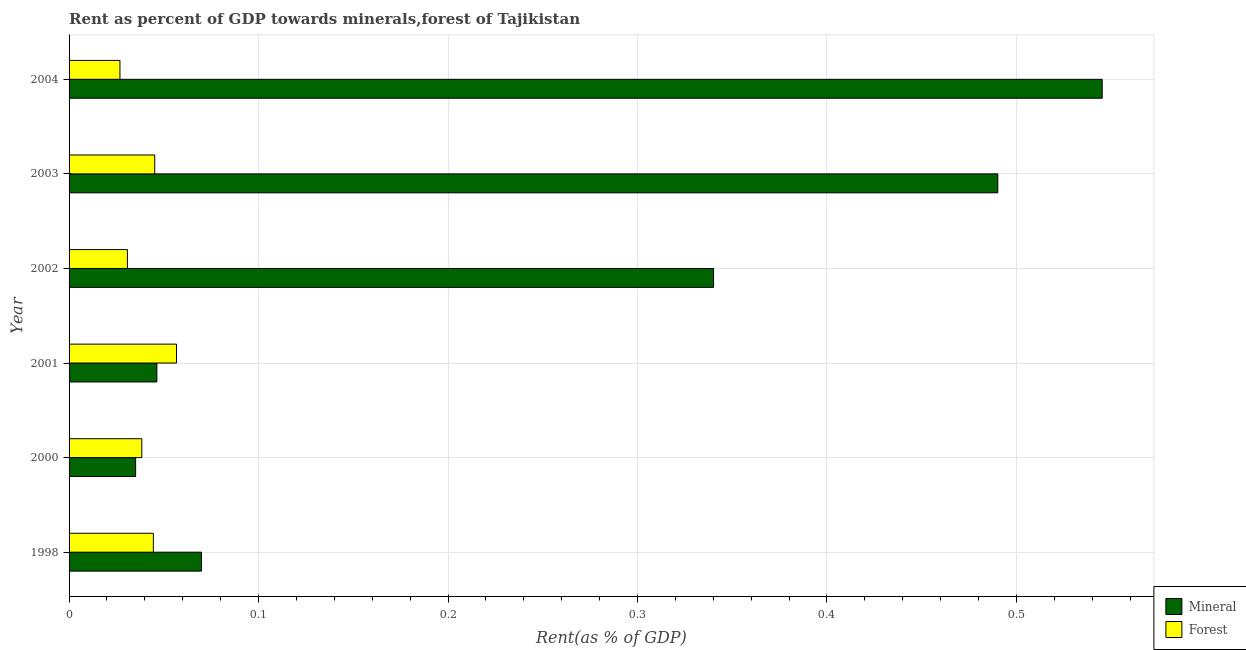How many groups of bars are there?
Ensure brevity in your answer.  6. Are the number of bars on each tick of the Y-axis equal?
Offer a very short reply. Yes. How many bars are there on the 5th tick from the bottom?
Provide a succinct answer. 2. In how many cases, is the number of bars for a given year not equal to the number of legend labels?
Ensure brevity in your answer.  0. What is the forest rent in 1998?
Keep it short and to the point. 0.04. Across all years, what is the maximum mineral rent?
Your answer should be compact. 0.55. Across all years, what is the minimum mineral rent?
Offer a terse response. 0.04. In which year was the forest rent maximum?
Provide a short and direct response. 2001. In which year was the mineral rent minimum?
Keep it short and to the point. 2000. What is the total mineral rent in the graph?
Provide a succinct answer. 1.53. What is the difference between the forest rent in 2001 and that in 2003?
Your answer should be compact. 0.01. What is the difference between the forest rent in 2004 and the mineral rent in 1998?
Provide a succinct answer. -0.04. What is the average forest rent per year?
Offer a very short reply. 0.04. In the year 2003, what is the difference between the forest rent and mineral rent?
Give a very brief answer. -0.45. What is the ratio of the mineral rent in 2000 to that in 2001?
Give a very brief answer. 0.76. What is the difference between the highest and the second highest mineral rent?
Give a very brief answer. 0.06. What is the difference between the highest and the lowest mineral rent?
Offer a very short reply. 0.51. In how many years, is the forest rent greater than the average forest rent taken over all years?
Your response must be concise. 3. What does the 1st bar from the top in 2003 represents?
Your answer should be compact. Forest. What does the 2nd bar from the bottom in 1998 represents?
Provide a succinct answer. Forest. How many years are there in the graph?
Keep it short and to the point. 6. Does the graph contain grids?
Your answer should be compact. Yes. What is the title of the graph?
Offer a very short reply. Rent as percent of GDP towards minerals,forest of Tajikistan. What is the label or title of the X-axis?
Your response must be concise. Rent(as % of GDP). What is the Rent(as % of GDP) of Mineral in 1998?
Your response must be concise. 0.07. What is the Rent(as % of GDP) in Forest in 1998?
Your answer should be compact. 0.04. What is the Rent(as % of GDP) in Mineral in 2000?
Offer a terse response. 0.04. What is the Rent(as % of GDP) in Forest in 2000?
Ensure brevity in your answer.  0.04. What is the Rent(as % of GDP) in Mineral in 2001?
Provide a succinct answer. 0.05. What is the Rent(as % of GDP) in Forest in 2001?
Keep it short and to the point. 0.06. What is the Rent(as % of GDP) of Mineral in 2002?
Your response must be concise. 0.34. What is the Rent(as % of GDP) of Forest in 2002?
Keep it short and to the point. 0.03. What is the Rent(as % of GDP) in Mineral in 2003?
Keep it short and to the point. 0.49. What is the Rent(as % of GDP) in Forest in 2003?
Your answer should be compact. 0.05. What is the Rent(as % of GDP) of Mineral in 2004?
Your answer should be very brief. 0.55. What is the Rent(as % of GDP) of Forest in 2004?
Give a very brief answer. 0.03. Across all years, what is the maximum Rent(as % of GDP) of Mineral?
Offer a very short reply. 0.55. Across all years, what is the maximum Rent(as % of GDP) in Forest?
Offer a very short reply. 0.06. Across all years, what is the minimum Rent(as % of GDP) of Mineral?
Your response must be concise. 0.04. Across all years, what is the minimum Rent(as % of GDP) in Forest?
Give a very brief answer. 0.03. What is the total Rent(as % of GDP) of Mineral in the graph?
Keep it short and to the point. 1.53. What is the total Rent(as % of GDP) in Forest in the graph?
Make the answer very short. 0.24. What is the difference between the Rent(as % of GDP) of Mineral in 1998 and that in 2000?
Make the answer very short. 0.03. What is the difference between the Rent(as % of GDP) in Forest in 1998 and that in 2000?
Provide a short and direct response. 0.01. What is the difference between the Rent(as % of GDP) of Mineral in 1998 and that in 2001?
Give a very brief answer. 0.02. What is the difference between the Rent(as % of GDP) of Forest in 1998 and that in 2001?
Your response must be concise. -0.01. What is the difference between the Rent(as % of GDP) of Mineral in 1998 and that in 2002?
Provide a succinct answer. -0.27. What is the difference between the Rent(as % of GDP) in Forest in 1998 and that in 2002?
Provide a succinct answer. 0.01. What is the difference between the Rent(as % of GDP) in Mineral in 1998 and that in 2003?
Offer a very short reply. -0.42. What is the difference between the Rent(as % of GDP) in Forest in 1998 and that in 2003?
Give a very brief answer. -0. What is the difference between the Rent(as % of GDP) in Mineral in 1998 and that in 2004?
Keep it short and to the point. -0.48. What is the difference between the Rent(as % of GDP) of Forest in 1998 and that in 2004?
Provide a short and direct response. 0.02. What is the difference between the Rent(as % of GDP) of Mineral in 2000 and that in 2001?
Give a very brief answer. -0.01. What is the difference between the Rent(as % of GDP) of Forest in 2000 and that in 2001?
Provide a succinct answer. -0.02. What is the difference between the Rent(as % of GDP) of Mineral in 2000 and that in 2002?
Offer a terse response. -0.3. What is the difference between the Rent(as % of GDP) of Forest in 2000 and that in 2002?
Offer a terse response. 0.01. What is the difference between the Rent(as % of GDP) of Mineral in 2000 and that in 2003?
Your answer should be compact. -0.46. What is the difference between the Rent(as % of GDP) of Forest in 2000 and that in 2003?
Provide a succinct answer. -0.01. What is the difference between the Rent(as % of GDP) of Mineral in 2000 and that in 2004?
Provide a short and direct response. -0.51. What is the difference between the Rent(as % of GDP) in Forest in 2000 and that in 2004?
Offer a very short reply. 0.01. What is the difference between the Rent(as % of GDP) of Mineral in 2001 and that in 2002?
Keep it short and to the point. -0.29. What is the difference between the Rent(as % of GDP) of Forest in 2001 and that in 2002?
Provide a short and direct response. 0.03. What is the difference between the Rent(as % of GDP) in Mineral in 2001 and that in 2003?
Provide a succinct answer. -0.44. What is the difference between the Rent(as % of GDP) in Forest in 2001 and that in 2003?
Give a very brief answer. 0.01. What is the difference between the Rent(as % of GDP) of Mineral in 2001 and that in 2004?
Give a very brief answer. -0.5. What is the difference between the Rent(as % of GDP) in Forest in 2001 and that in 2004?
Ensure brevity in your answer.  0.03. What is the difference between the Rent(as % of GDP) of Mineral in 2002 and that in 2003?
Ensure brevity in your answer.  -0.15. What is the difference between the Rent(as % of GDP) in Forest in 2002 and that in 2003?
Offer a very short reply. -0.01. What is the difference between the Rent(as % of GDP) in Mineral in 2002 and that in 2004?
Ensure brevity in your answer.  -0.21. What is the difference between the Rent(as % of GDP) in Forest in 2002 and that in 2004?
Provide a short and direct response. 0. What is the difference between the Rent(as % of GDP) of Mineral in 2003 and that in 2004?
Provide a short and direct response. -0.06. What is the difference between the Rent(as % of GDP) of Forest in 2003 and that in 2004?
Your response must be concise. 0.02. What is the difference between the Rent(as % of GDP) of Mineral in 1998 and the Rent(as % of GDP) of Forest in 2000?
Ensure brevity in your answer.  0.03. What is the difference between the Rent(as % of GDP) in Mineral in 1998 and the Rent(as % of GDP) in Forest in 2001?
Ensure brevity in your answer.  0.01. What is the difference between the Rent(as % of GDP) in Mineral in 1998 and the Rent(as % of GDP) in Forest in 2002?
Offer a very short reply. 0.04. What is the difference between the Rent(as % of GDP) in Mineral in 1998 and the Rent(as % of GDP) in Forest in 2003?
Give a very brief answer. 0.02. What is the difference between the Rent(as % of GDP) in Mineral in 1998 and the Rent(as % of GDP) in Forest in 2004?
Offer a terse response. 0.04. What is the difference between the Rent(as % of GDP) of Mineral in 2000 and the Rent(as % of GDP) of Forest in 2001?
Your answer should be very brief. -0.02. What is the difference between the Rent(as % of GDP) in Mineral in 2000 and the Rent(as % of GDP) in Forest in 2002?
Provide a succinct answer. 0. What is the difference between the Rent(as % of GDP) in Mineral in 2000 and the Rent(as % of GDP) in Forest in 2003?
Your response must be concise. -0.01. What is the difference between the Rent(as % of GDP) of Mineral in 2000 and the Rent(as % of GDP) of Forest in 2004?
Provide a succinct answer. 0.01. What is the difference between the Rent(as % of GDP) of Mineral in 2001 and the Rent(as % of GDP) of Forest in 2002?
Give a very brief answer. 0.02. What is the difference between the Rent(as % of GDP) in Mineral in 2001 and the Rent(as % of GDP) in Forest in 2003?
Give a very brief answer. 0. What is the difference between the Rent(as % of GDP) of Mineral in 2001 and the Rent(as % of GDP) of Forest in 2004?
Offer a very short reply. 0.02. What is the difference between the Rent(as % of GDP) in Mineral in 2002 and the Rent(as % of GDP) in Forest in 2003?
Offer a very short reply. 0.29. What is the difference between the Rent(as % of GDP) in Mineral in 2002 and the Rent(as % of GDP) in Forest in 2004?
Your answer should be compact. 0.31. What is the difference between the Rent(as % of GDP) in Mineral in 2003 and the Rent(as % of GDP) in Forest in 2004?
Keep it short and to the point. 0.46. What is the average Rent(as % of GDP) in Mineral per year?
Keep it short and to the point. 0.25. What is the average Rent(as % of GDP) in Forest per year?
Your answer should be very brief. 0.04. In the year 1998, what is the difference between the Rent(as % of GDP) in Mineral and Rent(as % of GDP) in Forest?
Your answer should be very brief. 0.03. In the year 2000, what is the difference between the Rent(as % of GDP) of Mineral and Rent(as % of GDP) of Forest?
Ensure brevity in your answer.  -0. In the year 2001, what is the difference between the Rent(as % of GDP) in Mineral and Rent(as % of GDP) in Forest?
Your answer should be very brief. -0.01. In the year 2002, what is the difference between the Rent(as % of GDP) of Mineral and Rent(as % of GDP) of Forest?
Make the answer very short. 0.31. In the year 2003, what is the difference between the Rent(as % of GDP) in Mineral and Rent(as % of GDP) in Forest?
Provide a succinct answer. 0.45. In the year 2004, what is the difference between the Rent(as % of GDP) of Mineral and Rent(as % of GDP) of Forest?
Provide a short and direct response. 0.52. What is the ratio of the Rent(as % of GDP) in Mineral in 1998 to that in 2000?
Provide a short and direct response. 1.99. What is the ratio of the Rent(as % of GDP) in Forest in 1998 to that in 2000?
Ensure brevity in your answer.  1.16. What is the ratio of the Rent(as % of GDP) of Mineral in 1998 to that in 2001?
Give a very brief answer. 1.51. What is the ratio of the Rent(as % of GDP) of Forest in 1998 to that in 2001?
Offer a terse response. 0.78. What is the ratio of the Rent(as % of GDP) of Mineral in 1998 to that in 2002?
Keep it short and to the point. 0.21. What is the ratio of the Rent(as % of GDP) of Forest in 1998 to that in 2002?
Offer a very short reply. 1.44. What is the ratio of the Rent(as % of GDP) in Mineral in 1998 to that in 2003?
Keep it short and to the point. 0.14. What is the ratio of the Rent(as % of GDP) in Forest in 1998 to that in 2003?
Ensure brevity in your answer.  0.98. What is the ratio of the Rent(as % of GDP) of Mineral in 1998 to that in 2004?
Keep it short and to the point. 0.13. What is the ratio of the Rent(as % of GDP) of Forest in 1998 to that in 2004?
Your answer should be very brief. 1.66. What is the ratio of the Rent(as % of GDP) of Mineral in 2000 to that in 2001?
Ensure brevity in your answer.  0.76. What is the ratio of the Rent(as % of GDP) of Forest in 2000 to that in 2001?
Give a very brief answer. 0.68. What is the ratio of the Rent(as % of GDP) in Mineral in 2000 to that in 2002?
Your answer should be very brief. 0.1. What is the ratio of the Rent(as % of GDP) of Forest in 2000 to that in 2002?
Make the answer very short. 1.25. What is the ratio of the Rent(as % of GDP) in Mineral in 2000 to that in 2003?
Keep it short and to the point. 0.07. What is the ratio of the Rent(as % of GDP) of Forest in 2000 to that in 2003?
Provide a short and direct response. 0.85. What is the ratio of the Rent(as % of GDP) in Mineral in 2000 to that in 2004?
Your answer should be compact. 0.06. What is the ratio of the Rent(as % of GDP) in Forest in 2000 to that in 2004?
Keep it short and to the point. 1.43. What is the ratio of the Rent(as % of GDP) in Mineral in 2001 to that in 2002?
Provide a succinct answer. 0.14. What is the ratio of the Rent(as % of GDP) of Forest in 2001 to that in 2002?
Make the answer very short. 1.84. What is the ratio of the Rent(as % of GDP) of Mineral in 2001 to that in 2003?
Offer a very short reply. 0.09. What is the ratio of the Rent(as % of GDP) in Forest in 2001 to that in 2003?
Make the answer very short. 1.25. What is the ratio of the Rent(as % of GDP) of Mineral in 2001 to that in 2004?
Your response must be concise. 0.09. What is the ratio of the Rent(as % of GDP) in Forest in 2001 to that in 2004?
Your answer should be compact. 2.11. What is the ratio of the Rent(as % of GDP) of Mineral in 2002 to that in 2003?
Give a very brief answer. 0.69. What is the ratio of the Rent(as % of GDP) of Forest in 2002 to that in 2003?
Your response must be concise. 0.68. What is the ratio of the Rent(as % of GDP) of Mineral in 2002 to that in 2004?
Give a very brief answer. 0.62. What is the ratio of the Rent(as % of GDP) of Forest in 2002 to that in 2004?
Your response must be concise. 1.15. What is the ratio of the Rent(as % of GDP) of Mineral in 2003 to that in 2004?
Keep it short and to the point. 0.9. What is the ratio of the Rent(as % of GDP) of Forest in 2003 to that in 2004?
Your answer should be very brief. 1.68. What is the difference between the highest and the second highest Rent(as % of GDP) of Mineral?
Make the answer very short. 0.06. What is the difference between the highest and the second highest Rent(as % of GDP) in Forest?
Give a very brief answer. 0.01. What is the difference between the highest and the lowest Rent(as % of GDP) in Mineral?
Offer a terse response. 0.51. What is the difference between the highest and the lowest Rent(as % of GDP) of Forest?
Your answer should be compact. 0.03. 